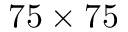<formula> <loc_0><loc_0><loc_500><loc_500>7 5 \times 7 5</formula> 